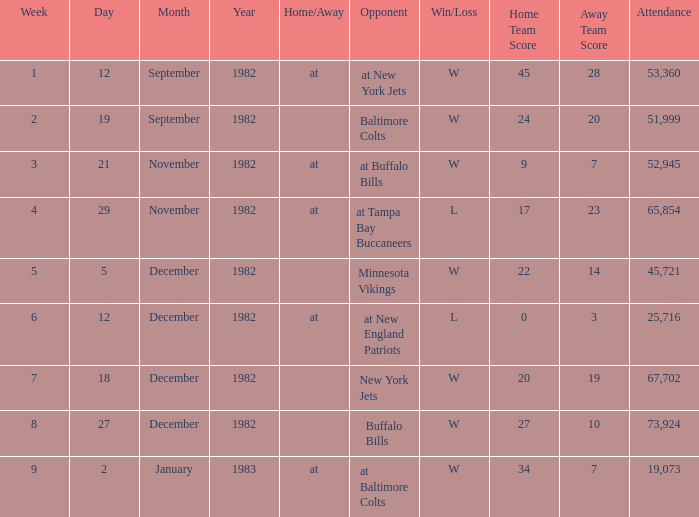What is the game's result where the number of attendees surpasses 67,702? W 27–10. 